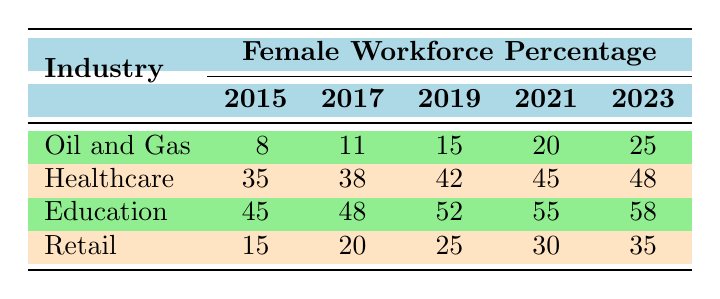What was the percentage of female workforce in the Oil and Gas industry in 2023? In the row for Oil and Gas under the year 2023, the female workforce percentage is listed as 25%. Therefore, this is the direct value we retrieve from the table.
Answer: 25 Which industry had the highest female workforce percentage in 2021? By looking at the percentages in the year 2021 across all industries, Education has the highest percentage at 55%. This can be deduced by comparing the values: Oil and Gas (20%), Healthcare (45%), Education (55%), and Retail (30%).
Answer: Education What is the average percentage of female workforce in the Retail industry from 2015 to 2023? The percentages of female workforce in Retail across the years are 15, 20, 25, 30, and 35. To find the average, we sum these values: 15 + 20 + 25 + 30 + 35 = 125. Then, we divide 125 by the number of years, which is 5. Thus, 125 / 5 = 25.
Answer: 25 Did the percentage of female workforce in the Healthcare industry increase from 2015 to 2023? In 2015, the percentage was 35%, and in 2023 it is 48%. Since 48% is greater than 35%, this indicates an increase in the female workforce percentage over this period.
Answer: Yes What was the total increase in the percentage of female workforce in Education from 2015 to 2023? The percentage in Education was 45% in 2015 and increased to 58% in 2023. The total increase can be calculated as 58% - 45% = 13%. Therefore, the increase is 13%.
Answer: 13% What is the difference in female workforce percentage between the Oil and Gas and Healthcare industries in 2019? In 2019, the percentage for Oil and Gas is 15% and for Healthcare, it is 42%. The difference can be calculated as 42% - 15% = 27%. Therefore, the difference in percentage is 27%.
Answer: 27% In which year was the percentage of female workforce in the Oil and Gas industry the lowest? By reviewing the numbers in the Oil and Gas row, the percentages for the years are 8% (2015), 11% (2017), 15% (2019), 20% (2021), and 25% (2023). The lowest value is 8%, indicating that 2015 was the year with the lowest percentage.
Answer: 2015 What trend is observed in the female workforce percentage in Education from 2015 to 2023? The percentages in Education show an increase: 45% (2015), 48% (2017), 52% (2019), 55% (2021), and 58% (2023). This shows a consistent upward trend, indicating a positive increase in female participation.
Answer: Increasing trend 